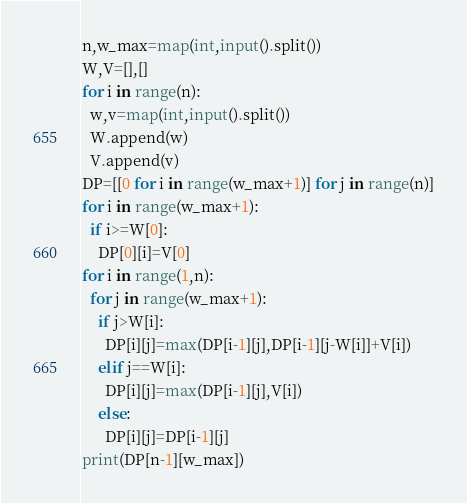<code> <loc_0><loc_0><loc_500><loc_500><_Python_>n,w_max=map(int,input().split())
W,V=[],[]
for i in range(n):
  w,v=map(int,input().split())
  W.append(w)
  V.append(v)
DP=[[0 for i in range(w_max+1)] for j in range(n)]
for i in range(w_max+1):
  if i>=W[0]:
    DP[0][i]=V[0]
for i in range(1,n):
  for j in range(w_max+1):
    if j>W[i]:
      DP[i][j]=max(DP[i-1][j],DP[i-1][j-W[i]]+V[i])
    elif j==W[i]:
      DP[i][j]=max(DP[i-1][j],V[i])
    else:
      DP[i][j]=DP[i-1][j]
print(DP[n-1][w_max])</code> 